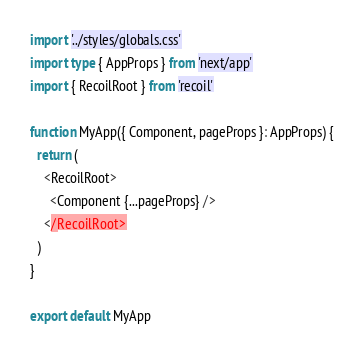<code> <loc_0><loc_0><loc_500><loc_500><_TypeScript_>import '../styles/globals.css'
import type { AppProps } from 'next/app'
import { RecoilRoot } from 'recoil'

function MyApp({ Component, pageProps }: AppProps) {
  return (
    <RecoilRoot>
      <Component {...pageProps} />
    </RecoilRoot>
  )
}

export default MyApp
</code> 